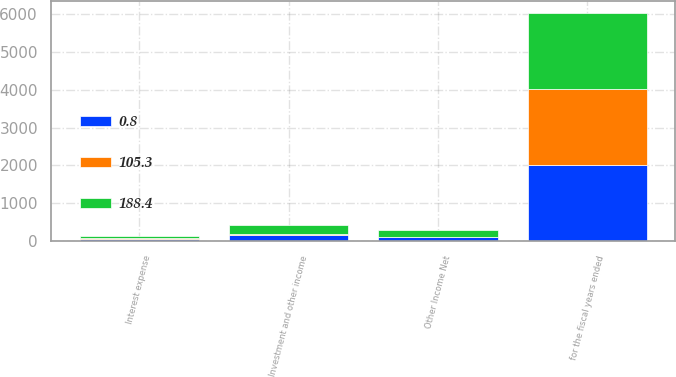Convert chart. <chart><loc_0><loc_0><loc_500><loc_500><stacked_bar_chart><ecel><fcel>for the fiscal years ended<fcel>Investment and other income<fcel>Interest expense<fcel>Other Income Net<nl><fcel>105.3<fcel>2015<fcel>40.4<fcel>39.6<fcel>0.8<nl><fcel>188.4<fcel>2014<fcel>235.8<fcel>47.4<fcel>188.4<nl><fcel>0.8<fcel>2013<fcel>152.2<fcel>46.9<fcel>105.3<nl></chart> 